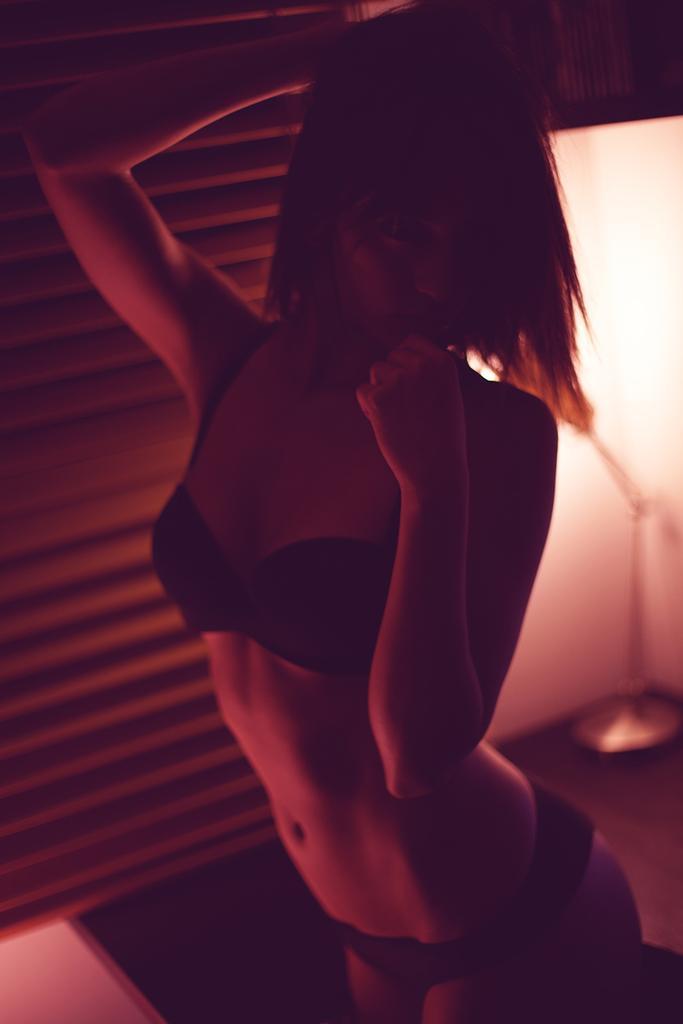Please provide a concise description of this image. In this picture I can see a girl in the middle, on the right side it looks like a metal rod. 